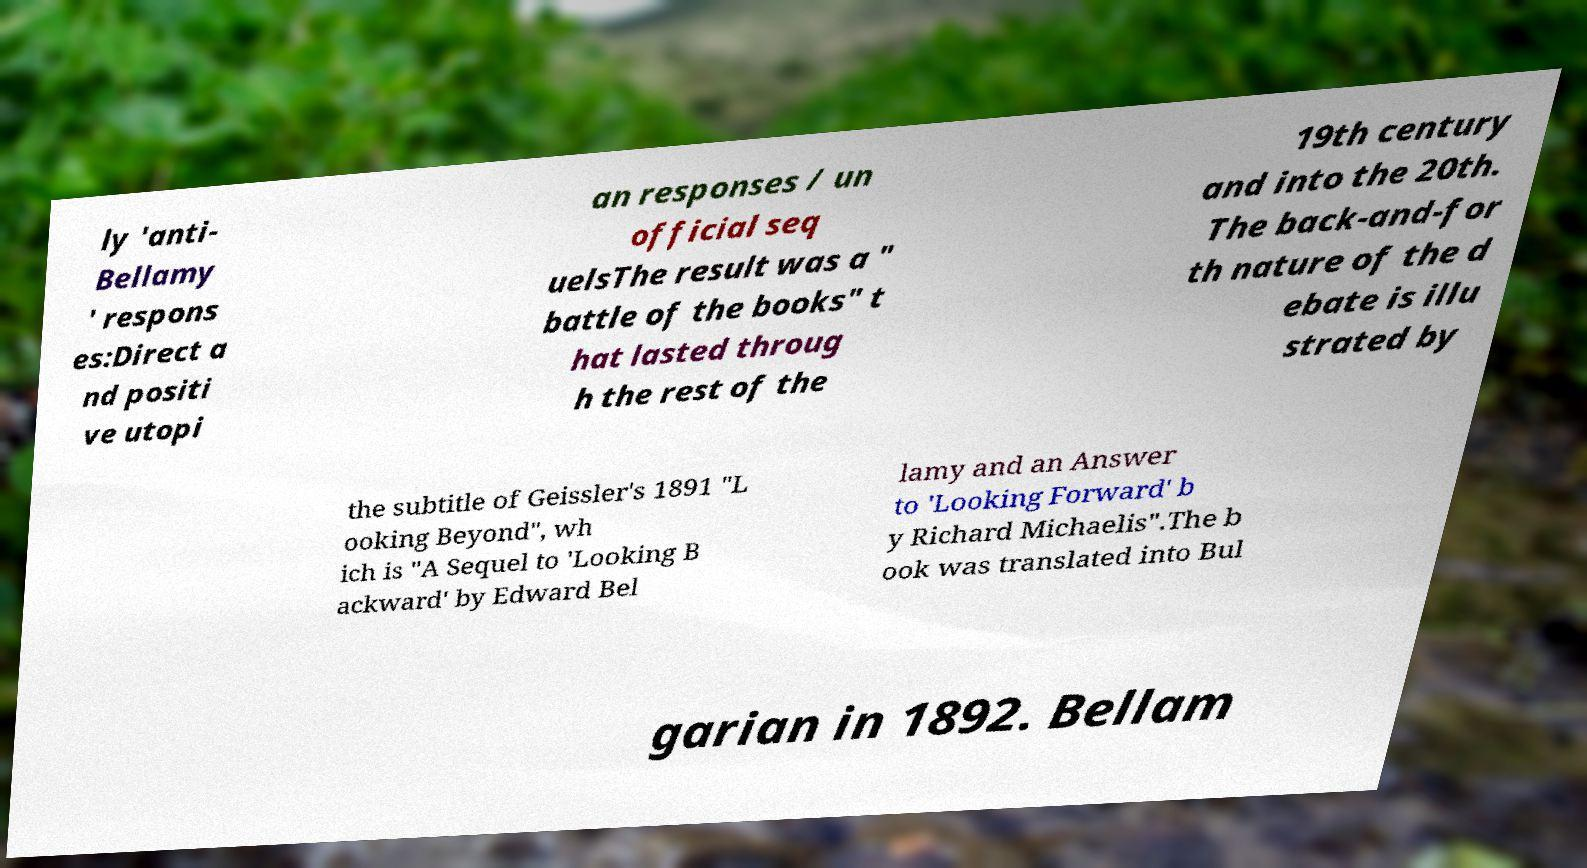Please read and relay the text visible in this image. What does it say? ly 'anti- Bellamy ' respons es:Direct a nd positi ve utopi an responses / un official seq uelsThe result was a " battle of the books" t hat lasted throug h the rest of the 19th century and into the 20th. The back-and-for th nature of the d ebate is illu strated by the subtitle of Geissler's 1891 "L ooking Beyond", wh ich is "A Sequel to 'Looking B ackward' by Edward Bel lamy and an Answer to 'Looking Forward' b y Richard Michaelis".The b ook was translated into Bul garian in 1892. Bellam 